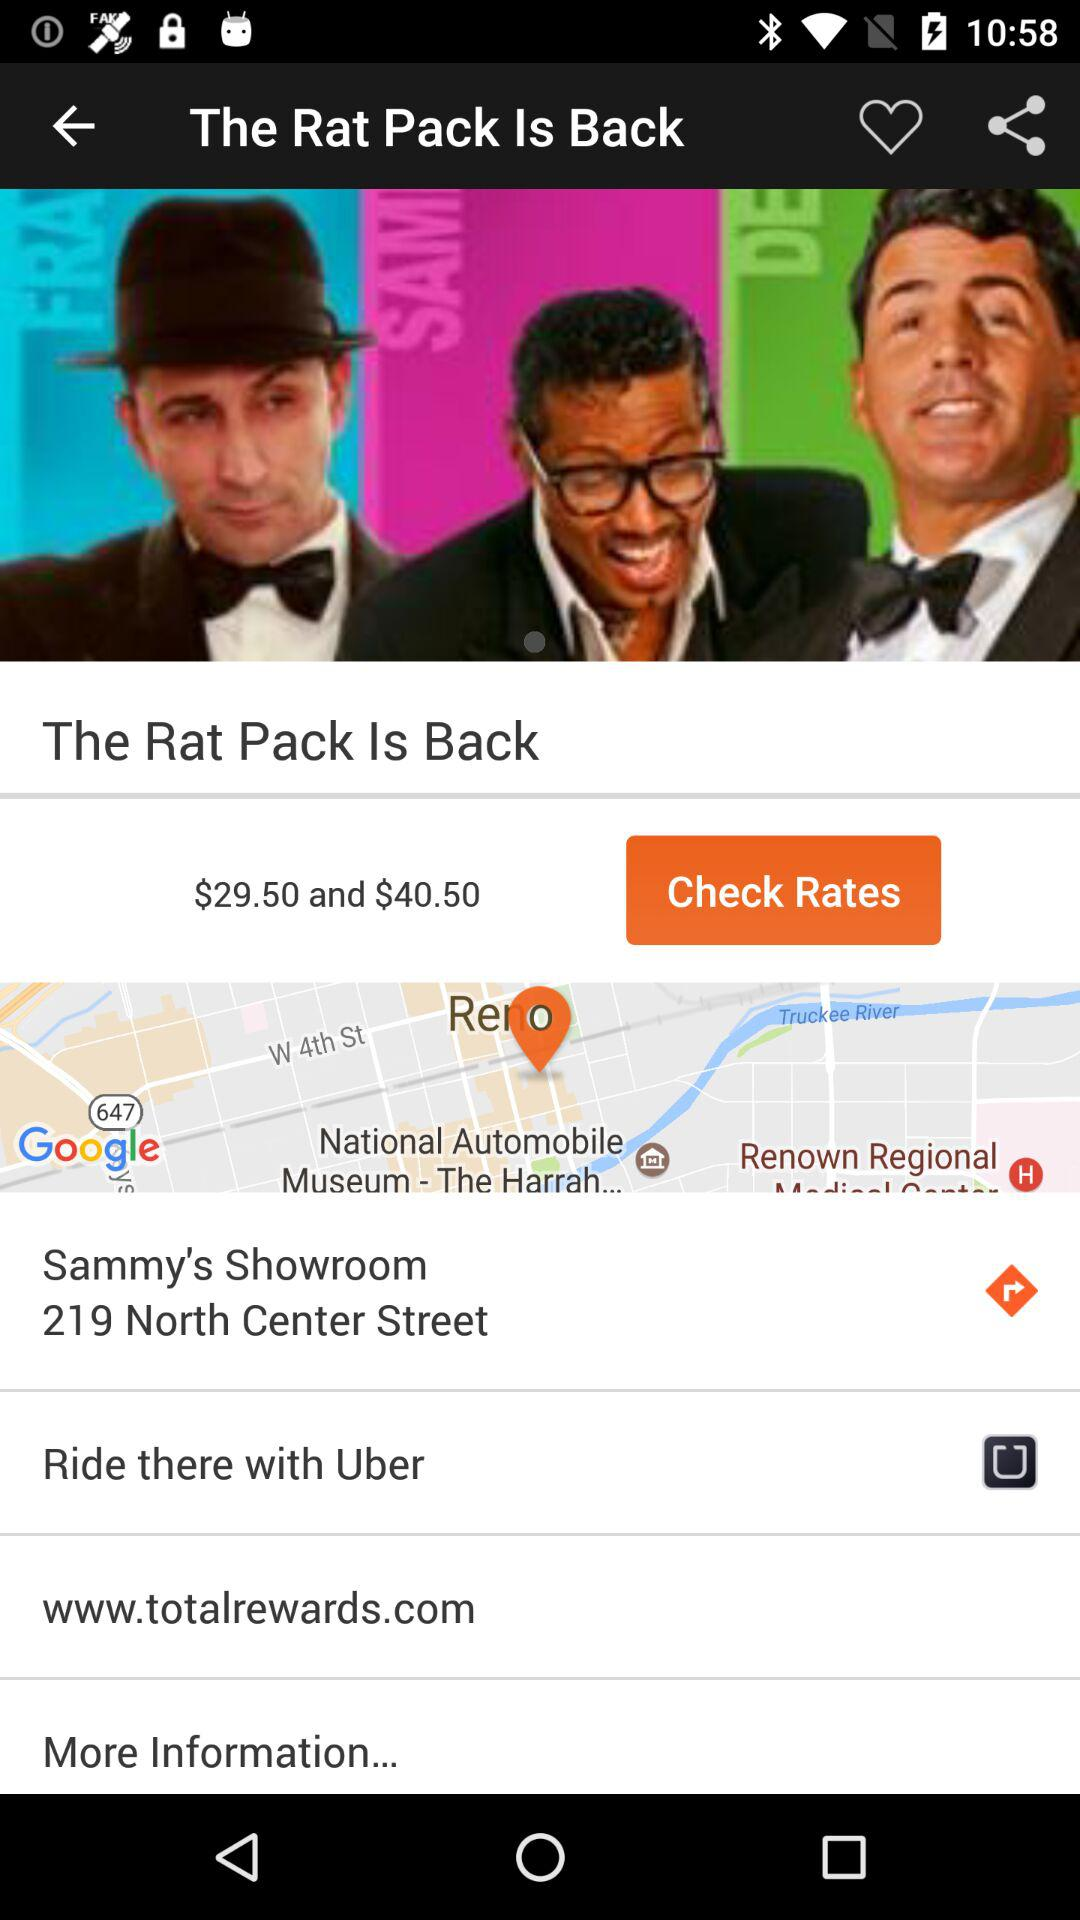What is the price? The prices are $29.50 and $40.50. 